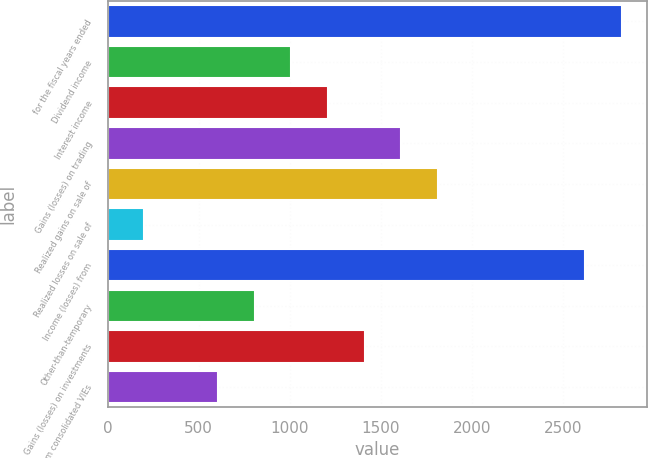<chart> <loc_0><loc_0><loc_500><loc_500><bar_chart><fcel>for the fiscal years ended<fcel>Dividend income<fcel>Interest income<fcel>Gains (losses) on trading<fcel>Realized gains on sale of<fcel>Realized losses on sale of<fcel>Income (losses) from<fcel>Other-than-temporary<fcel>Gains (losses) on investments<fcel>Gains from consolidated VIEs<nl><fcel>2820.68<fcel>1007.9<fcel>1209.32<fcel>1612.16<fcel>1813.58<fcel>202.22<fcel>2619.26<fcel>806.48<fcel>1410.74<fcel>605.06<nl></chart> 